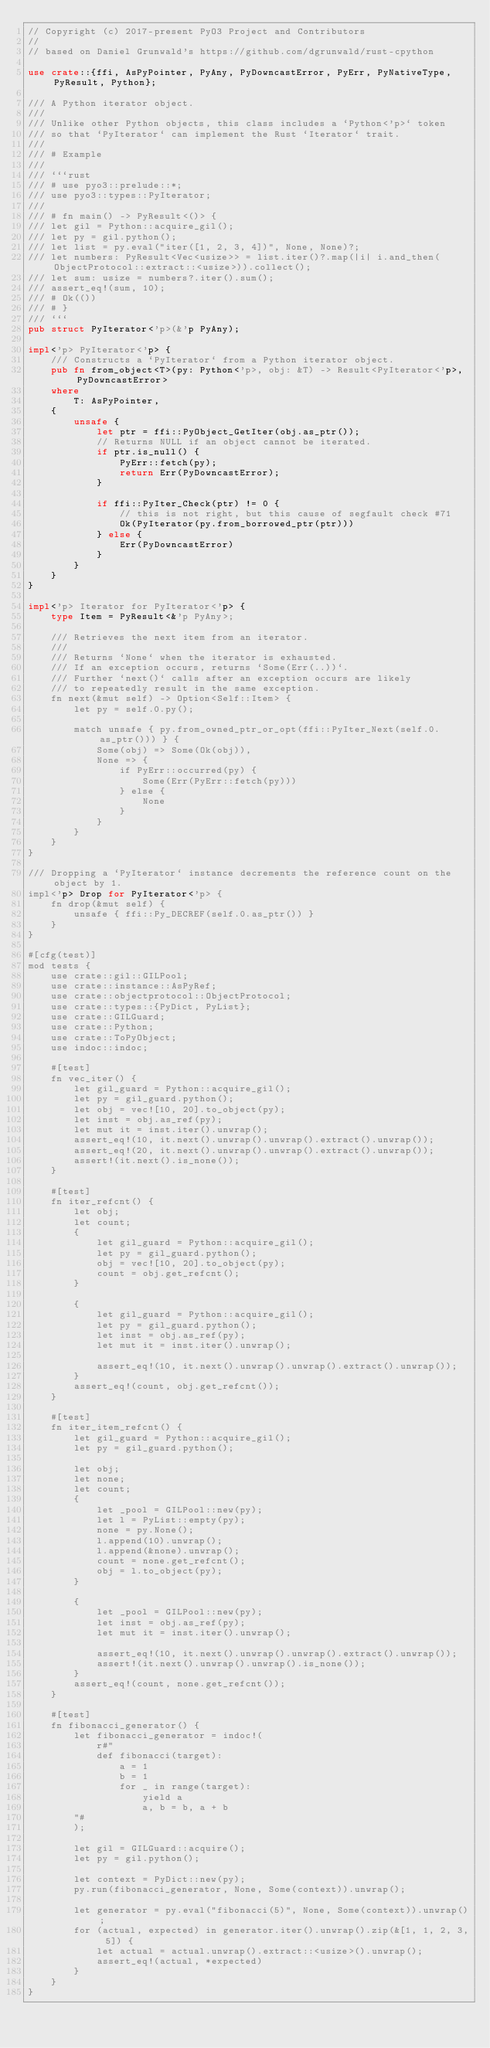Convert code to text. <code><loc_0><loc_0><loc_500><loc_500><_Rust_>// Copyright (c) 2017-present PyO3 Project and Contributors
//
// based on Daniel Grunwald's https://github.com/dgrunwald/rust-cpython

use crate::{ffi, AsPyPointer, PyAny, PyDowncastError, PyErr, PyNativeType, PyResult, Python};

/// A Python iterator object.
///
/// Unlike other Python objects, this class includes a `Python<'p>` token
/// so that `PyIterator` can implement the Rust `Iterator` trait.
///
/// # Example
///
/// ```rust
/// # use pyo3::prelude::*;
/// use pyo3::types::PyIterator;
///
/// # fn main() -> PyResult<()> {
/// let gil = Python::acquire_gil();
/// let py = gil.python();
/// let list = py.eval("iter([1, 2, 3, 4])", None, None)?;
/// let numbers: PyResult<Vec<usize>> = list.iter()?.map(|i| i.and_then(ObjectProtocol::extract::<usize>)).collect();
/// let sum: usize = numbers?.iter().sum();
/// assert_eq!(sum, 10);
/// # Ok(())
/// # }
/// ```
pub struct PyIterator<'p>(&'p PyAny);

impl<'p> PyIterator<'p> {
    /// Constructs a `PyIterator` from a Python iterator object.
    pub fn from_object<T>(py: Python<'p>, obj: &T) -> Result<PyIterator<'p>, PyDowncastError>
    where
        T: AsPyPointer,
    {
        unsafe {
            let ptr = ffi::PyObject_GetIter(obj.as_ptr());
            // Returns NULL if an object cannot be iterated.
            if ptr.is_null() {
                PyErr::fetch(py);
                return Err(PyDowncastError);
            }

            if ffi::PyIter_Check(ptr) != 0 {
                // this is not right, but this cause of segfault check #71
                Ok(PyIterator(py.from_borrowed_ptr(ptr)))
            } else {
                Err(PyDowncastError)
            }
        }
    }
}

impl<'p> Iterator for PyIterator<'p> {
    type Item = PyResult<&'p PyAny>;

    /// Retrieves the next item from an iterator.
    ///
    /// Returns `None` when the iterator is exhausted.
    /// If an exception occurs, returns `Some(Err(..))`.
    /// Further `next()` calls after an exception occurs are likely
    /// to repeatedly result in the same exception.
    fn next(&mut self) -> Option<Self::Item> {
        let py = self.0.py();

        match unsafe { py.from_owned_ptr_or_opt(ffi::PyIter_Next(self.0.as_ptr())) } {
            Some(obj) => Some(Ok(obj)),
            None => {
                if PyErr::occurred(py) {
                    Some(Err(PyErr::fetch(py)))
                } else {
                    None
                }
            }
        }
    }
}

/// Dropping a `PyIterator` instance decrements the reference count on the object by 1.
impl<'p> Drop for PyIterator<'p> {
    fn drop(&mut self) {
        unsafe { ffi::Py_DECREF(self.0.as_ptr()) }
    }
}

#[cfg(test)]
mod tests {
    use crate::gil::GILPool;
    use crate::instance::AsPyRef;
    use crate::objectprotocol::ObjectProtocol;
    use crate::types::{PyDict, PyList};
    use crate::GILGuard;
    use crate::Python;
    use crate::ToPyObject;
    use indoc::indoc;

    #[test]
    fn vec_iter() {
        let gil_guard = Python::acquire_gil();
        let py = gil_guard.python();
        let obj = vec![10, 20].to_object(py);
        let inst = obj.as_ref(py);
        let mut it = inst.iter().unwrap();
        assert_eq!(10, it.next().unwrap().unwrap().extract().unwrap());
        assert_eq!(20, it.next().unwrap().unwrap().extract().unwrap());
        assert!(it.next().is_none());
    }

    #[test]
    fn iter_refcnt() {
        let obj;
        let count;
        {
            let gil_guard = Python::acquire_gil();
            let py = gil_guard.python();
            obj = vec![10, 20].to_object(py);
            count = obj.get_refcnt();
        }

        {
            let gil_guard = Python::acquire_gil();
            let py = gil_guard.python();
            let inst = obj.as_ref(py);
            let mut it = inst.iter().unwrap();

            assert_eq!(10, it.next().unwrap().unwrap().extract().unwrap());
        }
        assert_eq!(count, obj.get_refcnt());
    }

    #[test]
    fn iter_item_refcnt() {
        let gil_guard = Python::acquire_gil();
        let py = gil_guard.python();

        let obj;
        let none;
        let count;
        {
            let _pool = GILPool::new(py);
            let l = PyList::empty(py);
            none = py.None();
            l.append(10).unwrap();
            l.append(&none).unwrap();
            count = none.get_refcnt();
            obj = l.to_object(py);
        }

        {
            let _pool = GILPool::new(py);
            let inst = obj.as_ref(py);
            let mut it = inst.iter().unwrap();

            assert_eq!(10, it.next().unwrap().unwrap().extract().unwrap());
            assert!(it.next().unwrap().unwrap().is_none());
        }
        assert_eq!(count, none.get_refcnt());
    }

    #[test]
    fn fibonacci_generator() {
        let fibonacci_generator = indoc!(
            r#"
            def fibonacci(target):
                a = 1
                b = 1
                for _ in range(target):
                    yield a
                    a, b = b, a + b
        "#
        );

        let gil = GILGuard::acquire();
        let py = gil.python();

        let context = PyDict::new(py);
        py.run(fibonacci_generator, None, Some(context)).unwrap();

        let generator = py.eval("fibonacci(5)", None, Some(context)).unwrap();
        for (actual, expected) in generator.iter().unwrap().zip(&[1, 1, 2, 3, 5]) {
            let actual = actual.unwrap().extract::<usize>().unwrap();
            assert_eq!(actual, *expected)
        }
    }
}
</code> 